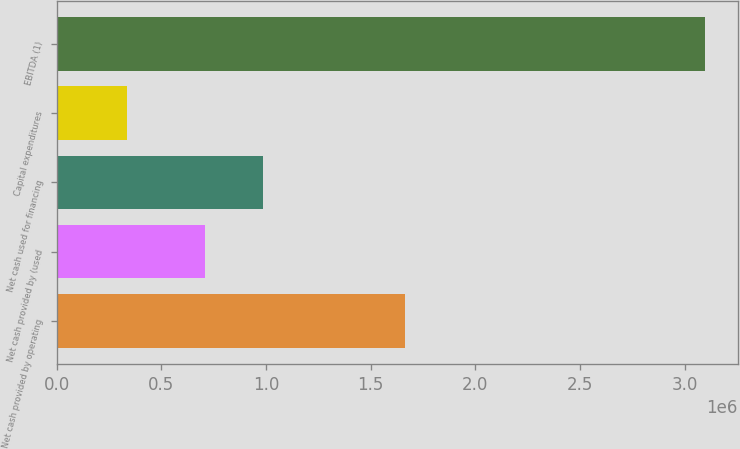Convert chart. <chart><loc_0><loc_0><loc_500><loc_500><bar_chart><fcel>Net cash provided by operating<fcel>Net cash provided by (used<fcel>Net cash used for financing<fcel>Capital expenditures<fcel>EBITDA (1)<nl><fcel>1.66269e+06<fcel>711104<fcel>987318<fcel>335263<fcel>3.0974e+06<nl></chart> 